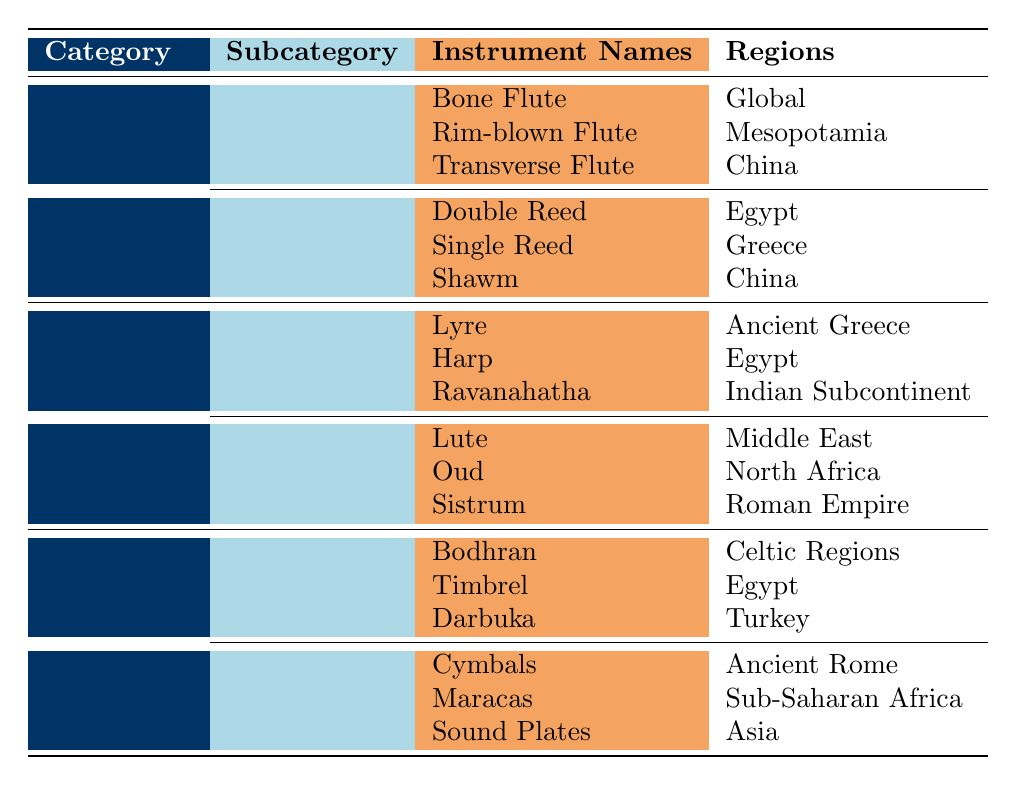What are the names of the instruments in the Woodwind category? The Woodwind category has two subcategories: Flutes and Reeds. The instruments under Flutes are Bone Flute, Rim-blown Flute, and Transverse Flute. Under Reeds, the instruments are Double Reed, Single Reed, and Shawm. Hence, the names are Bone Flute, Rim-blown Flute, Transverse Flute, Double Reed, Single Reed, and Shawm.
Answer: Bone Flute, Rim-blown Flute, Transverse Flute, Double Reed, Single Reed, Shawm Which percussion instruments are found in the regions of Egypt? The table indicates two subcategories under Percussion: Hand Drums and Idiophones. For Hand Drums, the instruments are Bodhran, Timbrel, and Darbuka, with Timbrel located in Egypt. For Idiophones, the instruments are Cymbals, Maracas, and Sound Plates, with no instruments in Egypt. Therefore, only the Timbrel is found in Egypt.
Answer: Timbrel Are there any string instruments in the Roman Empire region? The String category has two subcategories: Bowed and Plucked. The Bowed instruments listed are Lyre, Harp, and Ravanahatha, while the Plucked instruments are Lute, Oud, and Sistrum. The Plucked instruments include Sistrum from the Roman Empire. Thus, yes, there is one string instrument in the Roman Empire.
Answer: Yes How many total unique regions are associated with the Woodwind instruments? The Woodwind category comprises Flutes (with regions: Global, Mesopotamia, China) and Reeds (with regions: Egypt, Greece, China). Consolidating these, the unique regions are Global, Mesopotamia, China, Egypt, and Greece. Thus, the total number of unique regions is 5.
Answer: 5 What is the difference in the number of instrument types found in the String category compared to the Percussion category? The String category has two subcategories: Bowed (3 instruments) and Plucked (3 instruments), totaling 6 instruments. The Percussion category also has two subcategories: Hand Drums (3 instruments) and Idiophones (3 instruments), totaling 6 instruments as well. Thus, the difference is 0.
Answer: 0 Which ancient musical instrument region is common in both the Woodwind and String categories? By examining the regions of the Woodwind instruments (Global, Mesopotamia, China, Egypt, Greece) and the String instruments (Ancient Greece, Egypt, Indian Subcontinent, Middle East, North Africa, Roman Empire), the common regions are Egypt and Ancient Greece. Therefore, the common regions are Egypt and Ancient Greece.
Answer: Egypt, Ancient Greece 